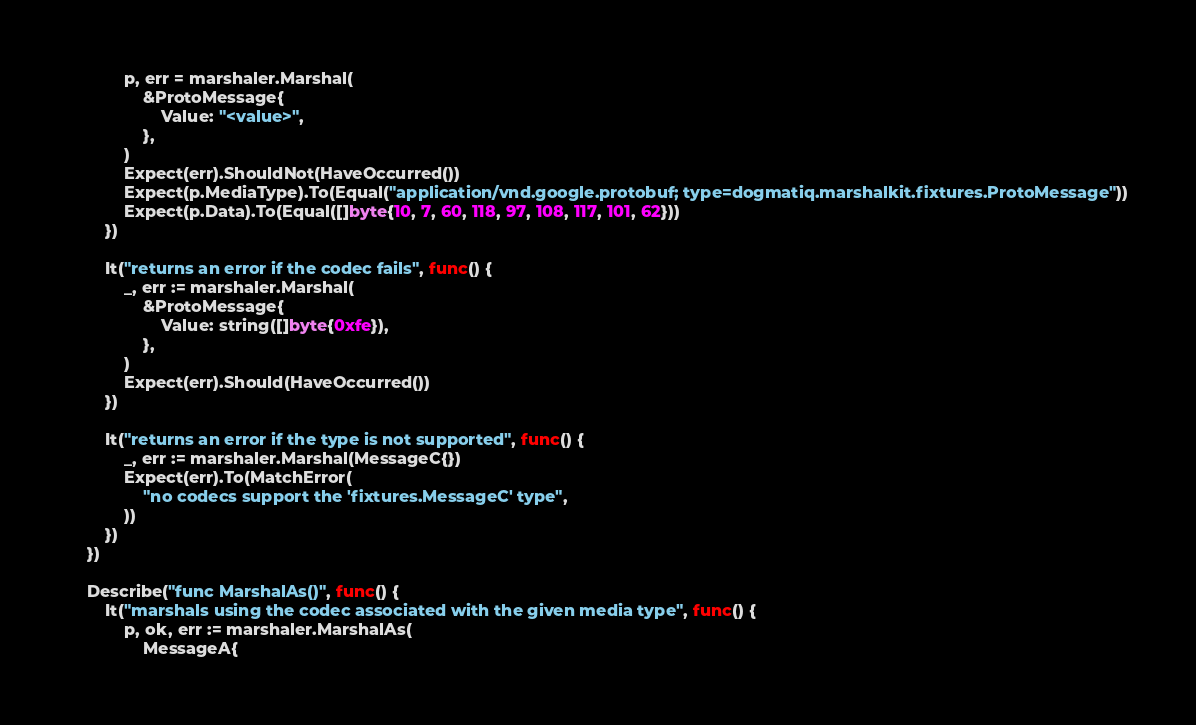<code> <loc_0><loc_0><loc_500><loc_500><_Go_>			p, err = marshaler.Marshal(
				&ProtoMessage{
					Value: "<value>",
				},
			)
			Expect(err).ShouldNot(HaveOccurred())
			Expect(p.MediaType).To(Equal("application/vnd.google.protobuf; type=dogmatiq.marshalkit.fixtures.ProtoMessage"))
			Expect(p.Data).To(Equal([]byte{10, 7, 60, 118, 97, 108, 117, 101, 62}))
		})

		It("returns an error if the codec fails", func() {
			_, err := marshaler.Marshal(
				&ProtoMessage{
					Value: string([]byte{0xfe}),
				},
			)
			Expect(err).Should(HaveOccurred())
		})

		It("returns an error if the type is not supported", func() {
			_, err := marshaler.Marshal(MessageC{})
			Expect(err).To(MatchError(
				"no codecs support the 'fixtures.MessageC' type",
			))
		})
	})

	Describe("func MarshalAs()", func() {
		It("marshals using the codec associated with the given media type", func() {
			p, ok, err := marshaler.MarshalAs(
				MessageA{</code> 